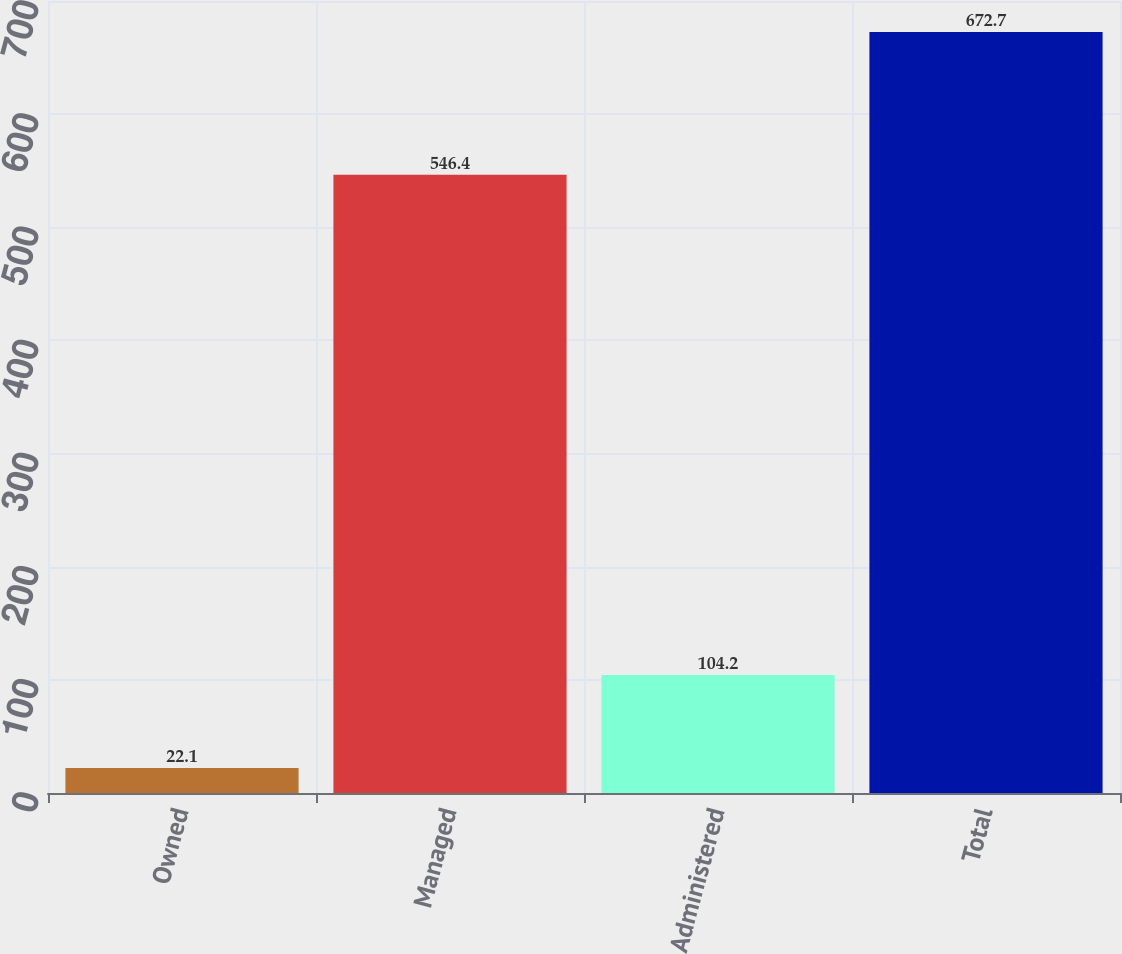Convert chart. <chart><loc_0><loc_0><loc_500><loc_500><bar_chart><fcel>Owned<fcel>Managed<fcel>Administered<fcel>Total<nl><fcel>22.1<fcel>546.4<fcel>104.2<fcel>672.7<nl></chart> 